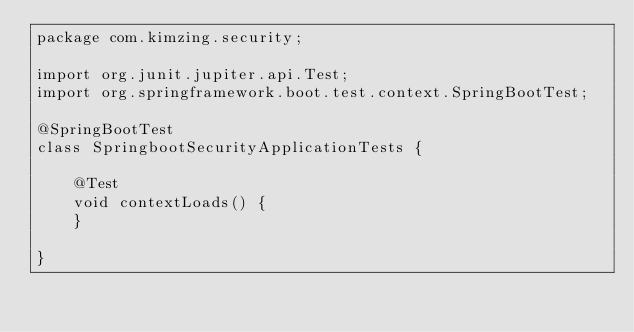<code> <loc_0><loc_0><loc_500><loc_500><_Java_>package com.kimzing.security;

import org.junit.jupiter.api.Test;
import org.springframework.boot.test.context.SpringBootTest;

@SpringBootTest
class SpringbootSecurityApplicationTests {

    @Test
    void contextLoads() {
    }

}
</code> 